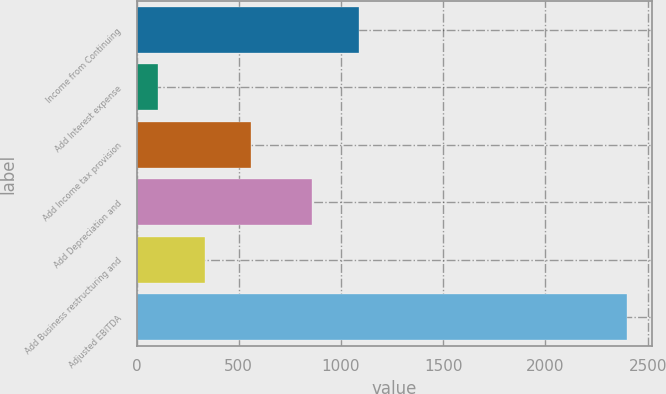Convert chart. <chart><loc_0><loc_0><loc_500><loc_500><bar_chart><fcel>Income from Continuing<fcel>Add Interest expense<fcel>Add Income tax provision<fcel>Add Depreciation and<fcel>Add Business restructuring and<fcel>Adjusted EBITDA<nl><fcel>1088.16<fcel>102.8<fcel>562.12<fcel>858.5<fcel>332.46<fcel>2399.4<nl></chart> 